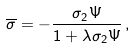Convert formula to latex. <formula><loc_0><loc_0><loc_500><loc_500>\overline { \sigma } = - \frac { \sigma _ { 2 } \Psi } { 1 + \lambda \sigma _ { 2 } \Psi } \, ,</formula> 